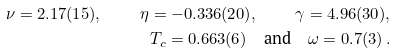Convert formula to latex. <formula><loc_0><loc_0><loc_500><loc_500>\nu = 2 . 1 7 ( 1 5 ) , \quad \eta = - 0 . 3 3 6 ( 2 0 ) , \quad \gamma = 4 . 9 6 ( 3 0 ) , \\ T _ { c } = 0 . 6 6 3 ( 6 ) \quad \text {and} \quad \omega = 0 . 7 ( 3 ) \, .</formula> 